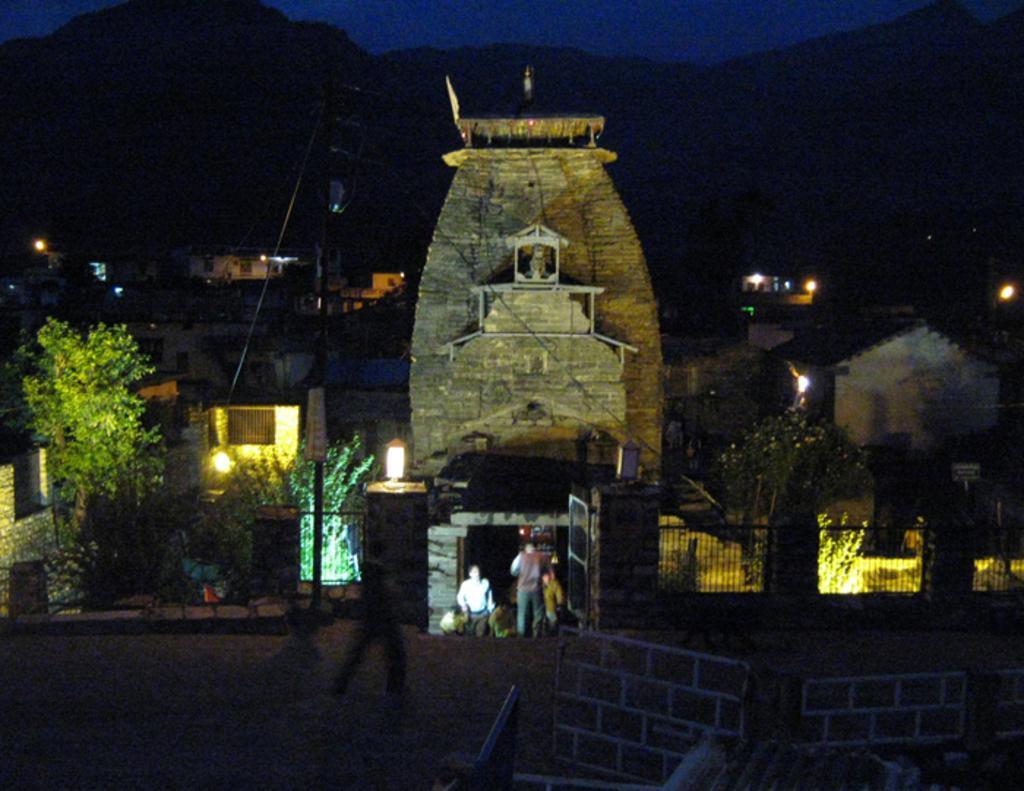Describe this image in one or two sentences. In this image, we can see a few houses. There are a few people. We can see a pole with some wires. We can see the ground and the sky. There are a few trees, plants. We can see the wall. We can see some lights. We can see some hills. 